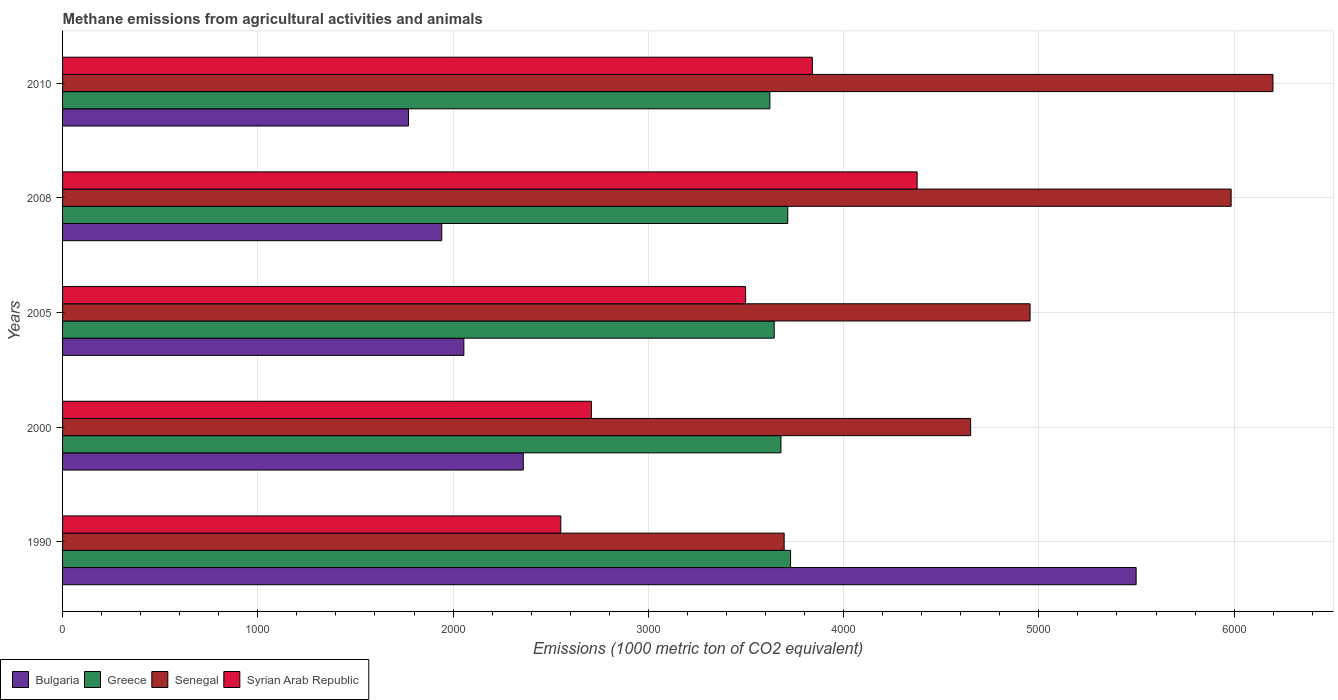How many different coloured bars are there?
Provide a succinct answer. 4. Are the number of bars on each tick of the Y-axis equal?
Your answer should be compact. Yes. How many bars are there on the 5th tick from the bottom?
Offer a very short reply. 4. In how many cases, is the number of bars for a given year not equal to the number of legend labels?
Your answer should be very brief. 0. What is the amount of methane emitted in Syrian Arab Republic in 2008?
Your response must be concise. 4376.8. Across all years, what is the maximum amount of methane emitted in Syrian Arab Republic?
Your answer should be very brief. 4376.8. Across all years, what is the minimum amount of methane emitted in Syrian Arab Republic?
Offer a very short reply. 2551.7. In which year was the amount of methane emitted in Bulgaria minimum?
Make the answer very short. 2010. What is the total amount of methane emitted in Syrian Arab Republic in the graph?
Make the answer very short. 1.70e+04. What is the difference between the amount of methane emitted in Greece in 2000 and that in 2005?
Ensure brevity in your answer.  34.7. What is the difference between the amount of methane emitted in Greece in 2010 and the amount of methane emitted in Bulgaria in 2005?
Offer a very short reply. 1567.2. What is the average amount of methane emitted in Greece per year?
Your answer should be compact. 3677.78. In the year 2000, what is the difference between the amount of methane emitted in Bulgaria and amount of methane emitted in Senegal?
Provide a short and direct response. -2291.2. What is the ratio of the amount of methane emitted in Senegal in 2000 to that in 2010?
Offer a terse response. 0.75. Is the difference between the amount of methane emitted in Bulgaria in 1990 and 2000 greater than the difference between the amount of methane emitted in Senegal in 1990 and 2000?
Make the answer very short. Yes. What is the difference between the highest and the second highest amount of methane emitted in Greece?
Your answer should be very brief. 14.4. What is the difference between the highest and the lowest amount of methane emitted in Senegal?
Keep it short and to the point. 2503.5. In how many years, is the amount of methane emitted in Greece greater than the average amount of methane emitted in Greece taken over all years?
Keep it short and to the point. 3. Is the sum of the amount of methane emitted in Senegal in 1990 and 2010 greater than the maximum amount of methane emitted in Greece across all years?
Ensure brevity in your answer.  Yes. Is it the case that in every year, the sum of the amount of methane emitted in Greece and amount of methane emitted in Syrian Arab Republic is greater than the sum of amount of methane emitted in Bulgaria and amount of methane emitted in Senegal?
Offer a terse response. No. What does the 3rd bar from the top in 2010 represents?
Your answer should be very brief. Greece. What does the 1st bar from the bottom in 2010 represents?
Your answer should be compact. Bulgaria. How many bars are there?
Keep it short and to the point. 20. Where does the legend appear in the graph?
Ensure brevity in your answer.  Bottom left. How many legend labels are there?
Your response must be concise. 4. How are the legend labels stacked?
Your response must be concise. Horizontal. What is the title of the graph?
Offer a terse response. Methane emissions from agricultural activities and animals. Does "Latvia" appear as one of the legend labels in the graph?
Provide a succinct answer. No. What is the label or title of the X-axis?
Your answer should be very brief. Emissions (1000 metric ton of CO2 equivalent). What is the label or title of the Y-axis?
Offer a terse response. Years. What is the Emissions (1000 metric ton of CO2 equivalent) of Bulgaria in 1990?
Give a very brief answer. 5498.3. What is the Emissions (1000 metric ton of CO2 equivalent) in Greece in 1990?
Your response must be concise. 3728.5. What is the Emissions (1000 metric ton of CO2 equivalent) of Senegal in 1990?
Your answer should be very brief. 3695.6. What is the Emissions (1000 metric ton of CO2 equivalent) of Syrian Arab Republic in 1990?
Your answer should be very brief. 2551.7. What is the Emissions (1000 metric ton of CO2 equivalent) in Bulgaria in 2000?
Keep it short and to the point. 2359.5. What is the Emissions (1000 metric ton of CO2 equivalent) of Greece in 2000?
Give a very brief answer. 3679.3. What is the Emissions (1000 metric ton of CO2 equivalent) in Senegal in 2000?
Offer a terse response. 4650.7. What is the Emissions (1000 metric ton of CO2 equivalent) in Syrian Arab Republic in 2000?
Ensure brevity in your answer.  2708.8. What is the Emissions (1000 metric ton of CO2 equivalent) in Bulgaria in 2005?
Provide a short and direct response. 2055.2. What is the Emissions (1000 metric ton of CO2 equivalent) of Greece in 2005?
Offer a terse response. 3644.6. What is the Emissions (1000 metric ton of CO2 equivalent) in Senegal in 2005?
Ensure brevity in your answer.  4955.1. What is the Emissions (1000 metric ton of CO2 equivalent) of Syrian Arab Republic in 2005?
Make the answer very short. 3498.3. What is the Emissions (1000 metric ton of CO2 equivalent) of Bulgaria in 2008?
Your response must be concise. 1942.2. What is the Emissions (1000 metric ton of CO2 equivalent) of Greece in 2008?
Keep it short and to the point. 3714.1. What is the Emissions (1000 metric ton of CO2 equivalent) of Senegal in 2008?
Provide a short and direct response. 5984.9. What is the Emissions (1000 metric ton of CO2 equivalent) of Syrian Arab Republic in 2008?
Your response must be concise. 4376.8. What is the Emissions (1000 metric ton of CO2 equivalent) in Bulgaria in 2010?
Ensure brevity in your answer.  1771.6. What is the Emissions (1000 metric ton of CO2 equivalent) in Greece in 2010?
Offer a very short reply. 3622.4. What is the Emissions (1000 metric ton of CO2 equivalent) in Senegal in 2010?
Ensure brevity in your answer.  6199.1. What is the Emissions (1000 metric ton of CO2 equivalent) of Syrian Arab Republic in 2010?
Provide a short and direct response. 3839.8. Across all years, what is the maximum Emissions (1000 metric ton of CO2 equivalent) of Bulgaria?
Your answer should be compact. 5498.3. Across all years, what is the maximum Emissions (1000 metric ton of CO2 equivalent) of Greece?
Ensure brevity in your answer.  3728.5. Across all years, what is the maximum Emissions (1000 metric ton of CO2 equivalent) of Senegal?
Your response must be concise. 6199.1. Across all years, what is the maximum Emissions (1000 metric ton of CO2 equivalent) of Syrian Arab Republic?
Your response must be concise. 4376.8. Across all years, what is the minimum Emissions (1000 metric ton of CO2 equivalent) of Bulgaria?
Provide a succinct answer. 1771.6. Across all years, what is the minimum Emissions (1000 metric ton of CO2 equivalent) in Greece?
Offer a terse response. 3622.4. Across all years, what is the minimum Emissions (1000 metric ton of CO2 equivalent) of Senegal?
Offer a very short reply. 3695.6. Across all years, what is the minimum Emissions (1000 metric ton of CO2 equivalent) of Syrian Arab Republic?
Your answer should be very brief. 2551.7. What is the total Emissions (1000 metric ton of CO2 equivalent) of Bulgaria in the graph?
Provide a succinct answer. 1.36e+04. What is the total Emissions (1000 metric ton of CO2 equivalent) in Greece in the graph?
Keep it short and to the point. 1.84e+04. What is the total Emissions (1000 metric ton of CO2 equivalent) in Senegal in the graph?
Keep it short and to the point. 2.55e+04. What is the total Emissions (1000 metric ton of CO2 equivalent) in Syrian Arab Republic in the graph?
Make the answer very short. 1.70e+04. What is the difference between the Emissions (1000 metric ton of CO2 equivalent) of Bulgaria in 1990 and that in 2000?
Keep it short and to the point. 3138.8. What is the difference between the Emissions (1000 metric ton of CO2 equivalent) in Greece in 1990 and that in 2000?
Make the answer very short. 49.2. What is the difference between the Emissions (1000 metric ton of CO2 equivalent) in Senegal in 1990 and that in 2000?
Make the answer very short. -955.1. What is the difference between the Emissions (1000 metric ton of CO2 equivalent) of Syrian Arab Republic in 1990 and that in 2000?
Offer a terse response. -157.1. What is the difference between the Emissions (1000 metric ton of CO2 equivalent) of Bulgaria in 1990 and that in 2005?
Your answer should be very brief. 3443.1. What is the difference between the Emissions (1000 metric ton of CO2 equivalent) of Greece in 1990 and that in 2005?
Provide a short and direct response. 83.9. What is the difference between the Emissions (1000 metric ton of CO2 equivalent) of Senegal in 1990 and that in 2005?
Keep it short and to the point. -1259.5. What is the difference between the Emissions (1000 metric ton of CO2 equivalent) in Syrian Arab Republic in 1990 and that in 2005?
Ensure brevity in your answer.  -946.6. What is the difference between the Emissions (1000 metric ton of CO2 equivalent) of Bulgaria in 1990 and that in 2008?
Give a very brief answer. 3556.1. What is the difference between the Emissions (1000 metric ton of CO2 equivalent) in Senegal in 1990 and that in 2008?
Ensure brevity in your answer.  -2289.3. What is the difference between the Emissions (1000 metric ton of CO2 equivalent) of Syrian Arab Republic in 1990 and that in 2008?
Provide a short and direct response. -1825.1. What is the difference between the Emissions (1000 metric ton of CO2 equivalent) in Bulgaria in 1990 and that in 2010?
Provide a succinct answer. 3726.7. What is the difference between the Emissions (1000 metric ton of CO2 equivalent) in Greece in 1990 and that in 2010?
Keep it short and to the point. 106.1. What is the difference between the Emissions (1000 metric ton of CO2 equivalent) in Senegal in 1990 and that in 2010?
Provide a short and direct response. -2503.5. What is the difference between the Emissions (1000 metric ton of CO2 equivalent) in Syrian Arab Republic in 1990 and that in 2010?
Your answer should be very brief. -1288.1. What is the difference between the Emissions (1000 metric ton of CO2 equivalent) in Bulgaria in 2000 and that in 2005?
Provide a succinct answer. 304.3. What is the difference between the Emissions (1000 metric ton of CO2 equivalent) of Greece in 2000 and that in 2005?
Keep it short and to the point. 34.7. What is the difference between the Emissions (1000 metric ton of CO2 equivalent) of Senegal in 2000 and that in 2005?
Your response must be concise. -304.4. What is the difference between the Emissions (1000 metric ton of CO2 equivalent) in Syrian Arab Republic in 2000 and that in 2005?
Provide a short and direct response. -789.5. What is the difference between the Emissions (1000 metric ton of CO2 equivalent) of Bulgaria in 2000 and that in 2008?
Keep it short and to the point. 417.3. What is the difference between the Emissions (1000 metric ton of CO2 equivalent) of Greece in 2000 and that in 2008?
Your response must be concise. -34.8. What is the difference between the Emissions (1000 metric ton of CO2 equivalent) of Senegal in 2000 and that in 2008?
Your answer should be very brief. -1334.2. What is the difference between the Emissions (1000 metric ton of CO2 equivalent) of Syrian Arab Republic in 2000 and that in 2008?
Your response must be concise. -1668. What is the difference between the Emissions (1000 metric ton of CO2 equivalent) of Bulgaria in 2000 and that in 2010?
Keep it short and to the point. 587.9. What is the difference between the Emissions (1000 metric ton of CO2 equivalent) in Greece in 2000 and that in 2010?
Provide a short and direct response. 56.9. What is the difference between the Emissions (1000 metric ton of CO2 equivalent) in Senegal in 2000 and that in 2010?
Keep it short and to the point. -1548.4. What is the difference between the Emissions (1000 metric ton of CO2 equivalent) in Syrian Arab Republic in 2000 and that in 2010?
Ensure brevity in your answer.  -1131. What is the difference between the Emissions (1000 metric ton of CO2 equivalent) of Bulgaria in 2005 and that in 2008?
Make the answer very short. 113. What is the difference between the Emissions (1000 metric ton of CO2 equivalent) of Greece in 2005 and that in 2008?
Offer a terse response. -69.5. What is the difference between the Emissions (1000 metric ton of CO2 equivalent) of Senegal in 2005 and that in 2008?
Provide a succinct answer. -1029.8. What is the difference between the Emissions (1000 metric ton of CO2 equivalent) of Syrian Arab Republic in 2005 and that in 2008?
Ensure brevity in your answer.  -878.5. What is the difference between the Emissions (1000 metric ton of CO2 equivalent) in Bulgaria in 2005 and that in 2010?
Offer a very short reply. 283.6. What is the difference between the Emissions (1000 metric ton of CO2 equivalent) in Greece in 2005 and that in 2010?
Your response must be concise. 22.2. What is the difference between the Emissions (1000 metric ton of CO2 equivalent) of Senegal in 2005 and that in 2010?
Give a very brief answer. -1244. What is the difference between the Emissions (1000 metric ton of CO2 equivalent) of Syrian Arab Republic in 2005 and that in 2010?
Ensure brevity in your answer.  -341.5. What is the difference between the Emissions (1000 metric ton of CO2 equivalent) of Bulgaria in 2008 and that in 2010?
Give a very brief answer. 170.6. What is the difference between the Emissions (1000 metric ton of CO2 equivalent) of Greece in 2008 and that in 2010?
Provide a succinct answer. 91.7. What is the difference between the Emissions (1000 metric ton of CO2 equivalent) of Senegal in 2008 and that in 2010?
Your answer should be very brief. -214.2. What is the difference between the Emissions (1000 metric ton of CO2 equivalent) in Syrian Arab Republic in 2008 and that in 2010?
Offer a very short reply. 537. What is the difference between the Emissions (1000 metric ton of CO2 equivalent) of Bulgaria in 1990 and the Emissions (1000 metric ton of CO2 equivalent) of Greece in 2000?
Keep it short and to the point. 1819. What is the difference between the Emissions (1000 metric ton of CO2 equivalent) of Bulgaria in 1990 and the Emissions (1000 metric ton of CO2 equivalent) of Senegal in 2000?
Provide a short and direct response. 847.6. What is the difference between the Emissions (1000 metric ton of CO2 equivalent) in Bulgaria in 1990 and the Emissions (1000 metric ton of CO2 equivalent) in Syrian Arab Republic in 2000?
Keep it short and to the point. 2789.5. What is the difference between the Emissions (1000 metric ton of CO2 equivalent) of Greece in 1990 and the Emissions (1000 metric ton of CO2 equivalent) of Senegal in 2000?
Provide a short and direct response. -922.2. What is the difference between the Emissions (1000 metric ton of CO2 equivalent) of Greece in 1990 and the Emissions (1000 metric ton of CO2 equivalent) of Syrian Arab Republic in 2000?
Make the answer very short. 1019.7. What is the difference between the Emissions (1000 metric ton of CO2 equivalent) of Senegal in 1990 and the Emissions (1000 metric ton of CO2 equivalent) of Syrian Arab Republic in 2000?
Keep it short and to the point. 986.8. What is the difference between the Emissions (1000 metric ton of CO2 equivalent) of Bulgaria in 1990 and the Emissions (1000 metric ton of CO2 equivalent) of Greece in 2005?
Offer a very short reply. 1853.7. What is the difference between the Emissions (1000 metric ton of CO2 equivalent) in Bulgaria in 1990 and the Emissions (1000 metric ton of CO2 equivalent) in Senegal in 2005?
Keep it short and to the point. 543.2. What is the difference between the Emissions (1000 metric ton of CO2 equivalent) of Bulgaria in 1990 and the Emissions (1000 metric ton of CO2 equivalent) of Syrian Arab Republic in 2005?
Provide a succinct answer. 2000. What is the difference between the Emissions (1000 metric ton of CO2 equivalent) of Greece in 1990 and the Emissions (1000 metric ton of CO2 equivalent) of Senegal in 2005?
Your response must be concise. -1226.6. What is the difference between the Emissions (1000 metric ton of CO2 equivalent) in Greece in 1990 and the Emissions (1000 metric ton of CO2 equivalent) in Syrian Arab Republic in 2005?
Give a very brief answer. 230.2. What is the difference between the Emissions (1000 metric ton of CO2 equivalent) of Senegal in 1990 and the Emissions (1000 metric ton of CO2 equivalent) of Syrian Arab Republic in 2005?
Ensure brevity in your answer.  197.3. What is the difference between the Emissions (1000 metric ton of CO2 equivalent) in Bulgaria in 1990 and the Emissions (1000 metric ton of CO2 equivalent) in Greece in 2008?
Make the answer very short. 1784.2. What is the difference between the Emissions (1000 metric ton of CO2 equivalent) in Bulgaria in 1990 and the Emissions (1000 metric ton of CO2 equivalent) in Senegal in 2008?
Keep it short and to the point. -486.6. What is the difference between the Emissions (1000 metric ton of CO2 equivalent) of Bulgaria in 1990 and the Emissions (1000 metric ton of CO2 equivalent) of Syrian Arab Republic in 2008?
Your answer should be very brief. 1121.5. What is the difference between the Emissions (1000 metric ton of CO2 equivalent) of Greece in 1990 and the Emissions (1000 metric ton of CO2 equivalent) of Senegal in 2008?
Offer a terse response. -2256.4. What is the difference between the Emissions (1000 metric ton of CO2 equivalent) in Greece in 1990 and the Emissions (1000 metric ton of CO2 equivalent) in Syrian Arab Republic in 2008?
Offer a terse response. -648.3. What is the difference between the Emissions (1000 metric ton of CO2 equivalent) in Senegal in 1990 and the Emissions (1000 metric ton of CO2 equivalent) in Syrian Arab Republic in 2008?
Make the answer very short. -681.2. What is the difference between the Emissions (1000 metric ton of CO2 equivalent) of Bulgaria in 1990 and the Emissions (1000 metric ton of CO2 equivalent) of Greece in 2010?
Your answer should be compact. 1875.9. What is the difference between the Emissions (1000 metric ton of CO2 equivalent) in Bulgaria in 1990 and the Emissions (1000 metric ton of CO2 equivalent) in Senegal in 2010?
Your response must be concise. -700.8. What is the difference between the Emissions (1000 metric ton of CO2 equivalent) in Bulgaria in 1990 and the Emissions (1000 metric ton of CO2 equivalent) in Syrian Arab Republic in 2010?
Make the answer very short. 1658.5. What is the difference between the Emissions (1000 metric ton of CO2 equivalent) of Greece in 1990 and the Emissions (1000 metric ton of CO2 equivalent) of Senegal in 2010?
Provide a short and direct response. -2470.6. What is the difference between the Emissions (1000 metric ton of CO2 equivalent) of Greece in 1990 and the Emissions (1000 metric ton of CO2 equivalent) of Syrian Arab Republic in 2010?
Your answer should be very brief. -111.3. What is the difference between the Emissions (1000 metric ton of CO2 equivalent) in Senegal in 1990 and the Emissions (1000 metric ton of CO2 equivalent) in Syrian Arab Republic in 2010?
Keep it short and to the point. -144.2. What is the difference between the Emissions (1000 metric ton of CO2 equivalent) in Bulgaria in 2000 and the Emissions (1000 metric ton of CO2 equivalent) in Greece in 2005?
Provide a short and direct response. -1285.1. What is the difference between the Emissions (1000 metric ton of CO2 equivalent) in Bulgaria in 2000 and the Emissions (1000 metric ton of CO2 equivalent) in Senegal in 2005?
Offer a very short reply. -2595.6. What is the difference between the Emissions (1000 metric ton of CO2 equivalent) in Bulgaria in 2000 and the Emissions (1000 metric ton of CO2 equivalent) in Syrian Arab Republic in 2005?
Offer a very short reply. -1138.8. What is the difference between the Emissions (1000 metric ton of CO2 equivalent) of Greece in 2000 and the Emissions (1000 metric ton of CO2 equivalent) of Senegal in 2005?
Provide a succinct answer. -1275.8. What is the difference between the Emissions (1000 metric ton of CO2 equivalent) in Greece in 2000 and the Emissions (1000 metric ton of CO2 equivalent) in Syrian Arab Republic in 2005?
Give a very brief answer. 181. What is the difference between the Emissions (1000 metric ton of CO2 equivalent) in Senegal in 2000 and the Emissions (1000 metric ton of CO2 equivalent) in Syrian Arab Republic in 2005?
Ensure brevity in your answer.  1152.4. What is the difference between the Emissions (1000 metric ton of CO2 equivalent) in Bulgaria in 2000 and the Emissions (1000 metric ton of CO2 equivalent) in Greece in 2008?
Make the answer very short. -1354.6. What is the difference between the Emissions (1000 metric ton of CO2 equivalent) of Bulgaria in 2000 and the Emissions (1000 metric ton of CO2 equivalent) of Senegal in 2008?
Offer a terse response. -3625.4. What is the difference between the Emissions (1000 metric ton of CO2 equivalent) in Bulgaria in 2000 and the Emissions (1000 metric ton of CO2 equivalent) in Syrian Arab Republic in 2008?
Offer a terse response. -2017.3. What is the difference between the Emissions (1000 metric ton of CO2 equivalent) of Greece in 2000 and the Emissions (1000 metric ton of CO2 equivalent) of Senegal in 2008?
Give a very brief answer. -2305.6. What is the difference between the Emissions (1000 metric ton of CO2 equivalent) of Greece in 2000 and the Emissions (1000 metric ton of CO2 equivalent) of Syrian Arab Republic in 2008?
Make the answer very short. -697.5. What is the difference between the Emissions (1000 metric ton of CO2 equivalent) of Senegal in 2000 and the Emissions (1000 metric ton of CO2 equivalent) of Syrian Arab Republic in 2008?
Your response must be concise. 273.9. What is the difference between the Emissions (1000 metric ton of CO2 equivalent) in Bulgaria in 2000 and the Emissions (1000 metric ton of CO2 equivalent) in Greece in 2010?
Offer a terse response. -1262.9. What is the difference between the Emissions (1000 metric ton of CO2 equivalent) in Bulgaria in 2000 and the Emissions (1000 metric ton of CO2 equivalent) in Senegal in 2010?
Offer a very short reply. -3839.6. What is the difference between the Emissions (1000 metric ton of CO2 equivalent) of Bulgaria in 2000 and the Emissions (1000 metric ton of CO2 equivalent) of Syrian Arab Republic in 2010?
Provide a short and direct response. -1480.3. What is the difference between the Emissions (1000 metric ton of CO2 equivalent) in Greece in 2000 and the Emissions (1000 metric ton of CO2 equivalent) in Senegal in 2010?
Offer a terse response. -2519.8. What is the difference between the Emissions (1000 metric ton of CO2 equivalent) of Greece in 2000 and the Emissions (1000 metric ton of CO2 equivalent) of Syrian Arab Republic in 2010?
Provide a short and direct response. -160.5. What is the difference between the Emissions (1000 metric ton of CO2 equivalent) in Senegal in 2000 and the Emissions (1000 metric ton of CO2 equivalent) in Syrian Arab Republic in 2010?
Offer a terse response. 810.9. What is the difference between the Emissions (1000 metric ton of CO2 equivalent) in Bulgaria in 2005 and the Emissions (1000 metric ton of CO2 equivalent) in Greece in 2008?
Ensure brevity in your answer.  -1658.9. What is the difference between the Emissions (1000 metric ton of CO2 equivalent) of Bulgaria in 2005 and the Emissions (1000 metric ton of CO2 equivalent) of Senegal in 2008?
Your answer should be very brief. -3929.7. What is the difference between the Emissions (1000 metric ton of CO2 equivalent) of Bulgaria in 2005 and the Emissions (1000 metric ton of CO2 equivalent) of Syrian Arab Republic in 2008?
Your answer should be compact. -2321.6. What is the difference between the Emissions (1000 metric ton of CO2 equivalent) of Greece in 2005 and the Emissions (1000 metric ton of CO2 equivalent) of Senegal in 2008?
Your response must be concise. -2340.3. What is the difference between the Emissions (1000 metric ton of CO2 equivalent) in Greece in 2005 and the Emissions (1000 metric ton of CO2 equivalent) in Syrian Arab Republic in 2008?
Keep it short and to the point. -732.2. What is the difference between the Emissions (1000 metric ton of CO2 equivalent) of Senegal in 2005 and the Emissions (1000 metric ton of CO2 equivalent) of Syrian Arab Republic in 2008?
Your answer should be compact. 578.3. What is the difference between the Emissions (1000 metric ton of CO2 equivalent) in Bulgaria in 2005 and the Emissions (1000 metric ton of CO2 equivalent) in Greece in 2010?
Provide a succinct answer. -1567.2. What is the difference between the Emissions (1000 metric ton of CO2 equivalent) in Bulgaria in 2005 and the Emissions (1000 metric ton of CO2 equivalent) in Senegal in 2010?
Offer a very short reply. -4143.9. What is the difference between the Emissions (1000 metric ton of CO2 equivalent) of Bulgaria in 2005 and the Emissions (1000 metric ton of CO2 equivalent) of Syrian Arab Republic in 2010?
Your response must be concise. -1784.6. What is the difference between the Emissions (1000 metric ton of CO2 equivalent) in Greece in 2005 and the Emissions (1000 metric ton of CO2 equivalent) in Senegal in 2010?
Offer a terse response. -2554.5. What is the difference between the Emissions (1000 metric ton of CO2 equivalent) of Greece in 2005 and the Emissions (1000 metric ton of CO2 equivalent) of Syrian Arab Republic in 2010?
Ensure brevity in your answer.  -195.2. What is the difference between the Emissions (1000 metric ton of CO2 equivalent) of Senegal in 2005 and the Emissions (1000 metric ton of CO2 equivalent) of Syrian Arab Republic in 2010?
Keep it short and to the point. 1115.3. What is the difference between the Emissions (1000 metric ton of CO2 equivalent) in Bulgaria in 2008 and the Emissions (1000 metric ton of CO2 equivalent) in Greece in 2010?
Your answer should be very brief. -1680.2. What is the difference between the Emissions (1000 metric ton of CO2 equivalent) in Bulgaria in 2008 and the Emissions (1000 metric ton of CO2 equivalent) in Senegal in 2010?
Keep it short and to the point. -4256.9. What is the difference between the Emissions (1000 metric ton of CO2 equivalent) in Bulgaria in 2008 and the Emissions (1000 metric ton of CO2 equivalent) in Syrian Arab Republic in 2010?
Offer a terse response. -1897.6. What is the difference between the Emissions (1000 metric ton of CO2 equivalent) in Greece in 2008 and the Emissions (1000 metric ton of CO2 equivalent) in Senegal in 2010?
Offer a very short reply. -2485. What is the difference between the Emissions (1000 metric ton of CO2 equivalent) in Greece in 2008 and the Emissions (1000 metric ton of CO2 equivalent) in Syrian Arab Republic in 2010?
Ensure brevity in your answer.  -125.7. What is the difference between the Emissions (1000 metric ton of CO2 equivalent) of Senegal in 2008 and the Emissions (1000 metric ton of CO2 equivalent) of Syrian Arab Republic in 2010?
Ensure brevity in your answer.  2145.1. What is the average Emissions (1000 metric ton of CO2 equivalent) in Bulgaria per year?
Ensure brevity in your answer.  2725.36. What is the average Emissions (1000 metric ton of CO2 equivalent) in Greece per year?
Your response must be concise. 3677.78. What is the average Emissions (1000 metric ton of CO2 equivalent) of Senegal per year?
Your response must be concise. 5097.08. What is the average Emissions (1000 metric ton of CO2 equivalent) in Syrian Arab Republic per year?
Ensure brevity in your answer.  3395.08. In the year 1990, what is the difference between the Emissions (1000 metric ton of CO2 equivalent) of Bulgaria and Emissions (1000 metric ton of CO2 equivalent) of Greece?
Offer a very short reply. 1769.8. In the year 1990, what is the difference between the Emissions (1000 metric ton of CO2 equivalent) of Bulgaria and Emissions (1000 metric ton of CO2 equivalent) of Senegal?
Offer a very short reply. 1802.7. In the year 1990, what is the difference between the Emissions (1000 metric ton of CO2 equivalent) of Bulgaria and Emissions (1000 metric ton of CO2 equivalent) of Syrian Arab Republic?
Your response must be concise. 2946.6. In the year 1990, what is the difference between the Emissions (1000 metric ton of CO2 equivalent) in Greece and Emissions (1000 metric ton of CO2 equivalent) in Senegal?
Offer a very short reply. 32.9. In the year 1990, what is the difference between the Emissions (1000 metric ton of CO2 equivalent) of Greece and Emissions (1000 metric ton of CO2 equivalent) of Syrian Arab Republic?
Give a very brief answer. 1176.8. In the year 1990, what is the difference between the Emissions (1000 metric ton of CO2 equivalent) of Senegal and Emissions (1000 metric ton of CO2 equivalent) of Syrian Arab Republic?
Provide a short and direct response. 1143.9. In the year 2000, what is the difference between the Emissions (1000 metric ton of CO2 equivalent) of Bulgaria and Emissions (1000 metric ton of CO2 equivalent) of Greece?
Offer a terse response. -1319.8. In the year 2000, what is the difference between the Emissions (1000 metric ton of CO2 equivalent) of Bulgaria and Emissions (1000 metric ton of CO2 equivalent) of Senegal?
Offer a terse response. -2291.2. In the year 2000, what is the difference between the Emissions (1000 metric ton of CO2 equivalent) of Bulgaria and Emissions (1000 metric ton of CO2 equivalent) of Syrian Arab Republic?
Your response must be concise. -349.3. In the year 2000, what is the difference between the Emissions (1000 metric ton of CO2 equivalent) of Greece and Emissions (1000 metric ton of CO2 equivalent) of Senegal?
Make the answer very short. -971.4. In the year 2000, what is the difference between the Emissions (1000 metric ton of CO2 equivalent) of Greece and Emissions (1000 metric ton of CO2 equivalent) of Syrian Arab Republic?
Your answer should be compact. 970.5. In the year 2000, what is the difference between the Emissions (1000 metric ton of CO2 equivalent) of Senegal and Emissions (1000 metric ton of CO2 equivalent) of Syrian Arab Republic?
Provide a short and direct response. 1941.9. In the year 2005, what is the difference between the Emissions (1000 metric ton of CO2 equivalent) in Bulgaria and Emissions (1000 metric ton of CO2 equivalent) in Greece?
Your answer should be very brief. -1589.4. In the year 2005, what is the difference between the Emissions (1000 metric ton of CO2 equivalent) in Bulgaria and Emissions (1000 metric ton of CO2 equivalent) in Senegal?
Your response must be concise. -2899.9. In the year 2005, what is the difference between the Emissions (1000 metric ton of CO2 equivalent) of Bulgaria and Emissions (1000 metric ton of CO2 equivalent) of Syrian Arab Republic?
Provide a short and direct response. -1443.1. In the year 2005, what is the difference between the Emissions (1000 metric ton of CO2 equivalent) in Greece and Emissions (1000 metric ton of CO2 equivalent) in Senegal?
Keep it short and to the point. -1310.5. In the year 2005, what is the difference between the Emissions (1000 metric ton of CO2 equivalent) in Greece and Emissions (1000 metric ton of CO2 equivalent) in Syrian Arab Republic?
Provide a short and direct response. 146.3. In the year 2005, what is the difference between the Emissions (1000 metric ton of CO2 equivalent) in Senegal and Emissions (1000 metric ton of CO2 equivalent) in Syrian Arab Republic?
Provide a short and direct response. 1456.8. In the year 2008, what is the difference between the Emissions (1000 metric ton of CO2 equivalent) of Bulgaria and Emissions (1000 metric ton of CO2 equivalent) of Greece?
Provide a short and direct response. -1771.9. In the year 2008, what is the difference between the Emissions (1000 metric ton of CO2 equivalent) in Bulgaria and Emissions (1000 metric ton of CO2 equivalent) in Senegal?
Make the answer very short. -4042.7. In the year 2008, what is the difference between the Emissions (1000 metric ton of CO2 equivalent) in Bulgaria and Emissions (1000 metric ton of CO2 equivalent) in Syrian Arab Republic?
Offer a very short reply. -2434.6. In the year 2008, what is the difference between the Emissions (1000 metric ton of CO2 equivalent) in Greece and Emissions (1000 metric ton of CO2 equivalent) in Senegal?
Offer a very short reply. -2270.8. In the year 2008, what is the difference between the Emissions (1000 metric ton of CO2 equivalent) in Greece and Emissions (1000 metric ton of CO2 equivalent) in Syrian Arab Republic?
Ensure brevity in your answer.  -662.7. In the year 2008, what is the difference between the Emissions (1000 metric ton of CO2 equivalent) of Senegal and Emissions (1000 metric ton of CO2 equivalent) of Syrian Arab Republic?
Provide a short and direct response. 1608.1. In the year 2010, what is the difference between the Emissions (1000 metric ton of CO2 equivalent) in Bulgaria and Emissions (1000 metric ton of CO2 equivalent) in Greece?
Your answer should be compact. -1850.8. In the year 2010, what is the difference between the Emissions (1000 metric ton of CO2 equivalent) in Bulgaria and Emissions (1000 metric ton of CO2 equivalent) in Senegal?
Keep it short and to the point. -4427.5. In the year 2010, what is the difference between the Emissions (1000 metric ton of CO2 equivalent) of Bulgaria and Emissions (1000 metric ton of CO2 equivalent) of Syrian Arab Republic?
Provide a succinct answer. -2068.2. In the year 2010, what is the difference between the Emissions (1000 metric ton of CO2 equivalent) in Greece and Emissions (1000 metric ton of CO2 equivalent) in Senegal?
Ensure brevity in your answer.  -2576.7. In the year 2010, what is the difference between the Emissions (1000 metric ton of CO2 equivalent) in Greece and Emissions (1000 metric ton of CO2 equivalent) in Syrian Arab Republic?
Offer a very short reply. -217.4. In the year 2010, what is the difference between the Emissions (1000 metric ton of CO2 equivalent) of Senegal and Emissions (1000 metric ton of CO2 equivalent) of Syrian Arab Republic?
Offer a terse response. 2359.3. What is the ratio of the Emissions (1000 metric ton of CO2 equivalent) in Bulgaria in 1990 to that in 2000?
Ensure brevity in your answer.  2.33. What is the ratio of the Emissions (1000 metric ton of CO2 equivalent) in Greece in 1990 to that in 2000?
Provide a succinct answer. 1.01. What is the ratio of the Emissions (1000 metric ton of CO2 equivalent) in Senegal in 1990 to that in 2000?
Provide a succinct answer. 0.79. What is the ratio of the Emissions (1000 metric ton of CO2 equivalent) in Syrian Arab Republic in 1990 to that in 2000?
Give a very brief answer. 0.94. What is the ratio of the Emissions (1000 metric ton of CO2 equivalent) of Bulgaria in 1990 to that in 2005?
Provide a short and direct response. 2.68. What is the ratio of the Emissions (1000 metric ton of CO2 equivalent) in Greece in 1990 to that in 2005?
Provide a succinct answer. 1.02. What is the ratio of the Emissions (1000 metric ton of CO2 equivalent) in Senegal in 1990 to that in 2005?
Your answer should be very brief. 0.75. What is the ratio of the Emissions (1000 metric ton of CO2 equivalent) of Syrian Arab Republic in 1990 to that in 2005?
Provide a succinct answer. 0.73. What is the ratio of the Emissions (1000 metric ton of CO2 equivalent) in Bulgaria in 1990 to that in 2008?
Provide a succinct answer. 2.83. What is the ratio of the Emissions (1000 metric ton of CO2 equivalent) of Greece in 1990 to that in 2008?
Provide a short and direct response. 1. What is the ratio of the Emissions (1000 metric ton of CO2 equivalent) in Senegal in 1990 to that in 2008?
Provide a short and direct response. 0.62. What is the ratio of the Emissions (1000 metric ton of CO2 equivalent) in Syrian Arab Republic in 1990 to that in 2008?
Your answer should be compact. 0.58. What is the ratio of the Emissions (1000 metric ton of CO2 equivalent) in Bulgaria in 1990 to that in 2010?
Your response must be concise. 3.1. What is the ratio of the Emissions (1000 metric ton of CO2 equivalent) of Greece in 1990 to that in 2010?
Your answer should be compact. 1.03. What is the ratio of the Emissions (1000 metric ton of CO2 equivalent) in Senegal in 1990 to that in 2010?
Offer a very short reply. 0.6. What is the ratio of the Emissions (1000 metric ton of CO2 equivalent) of Syrian Arab Republic in 1990 to that in 2010?
Provide a succinct answer. 0.66. What is the ratio of the Emissions (1000 metric ton of CO2 equivalent) in Bulgaria in 2000 to that in 2005?
Offer a very short reply. 1.15. What is the ratio of the Emissions (1000 metric ton of CO2 equivalent) of Greece in 2000 to that in 2005?
Keep it short and to the point. 1.01. What is the ratio of the Emissions (1000 metric ton of CO2 equivalent) of Senegal in 2000 to that in 2005?
Keep it short and to the point. 0.94. What is the ratio of the Emissions (1000 metric ton of CO2 equivalent) in Syrian Arab Republic in 2000 to that in 2005?
Ensure brevity in your answer.  0.77. What is the ratio of the Emissions (1000 metric ton of CO2 equivalent) in Bulgaria in 2000 to that in 2008?
Offer a terse response. 1.21. What is the ratio of the Emissions (1000 metric ton of CO2 equivalent) in Greece in 2000 to that in 2008?
Provide a short and direct response. 0.99. What is the ratio of the Emissions (1000 metric ton of CO2 equivalent) in Senegal in 2000 to that in 2008?
Offer a terse response. 0.78. What is the ratio of the Emissions (1000 metric ton of CO2 equivalent) of Syrian Arab Republic in 2000 to that in 2008?
Make the answer very short. 0.62. What is the ratio of the Emissions (1000 metric ton of CO2 equivalent) in Bulgaria in 2000 to that in 2010?
Your answer should be very brief. 1.33. What is the ratio of the Emissions (1000 metric ton of CO2 equivalent) of Greece in 2000 to that in 2010?
Provide a succinct answer. 1.02. What is the ratio of the Emissions (1000 metric ton of CO2 equivalent) of Senegal in 2000 to that in 2010?
Provide a succinct answer. 0.75. What is the ratio of the Emissions (1000 metric ton of CO2 equivalent) of Syrian Arab Republic in 2000 to that in 2010?
Provide a succinct answer. 0.71. What is the ratio of the Emissions (1000 metric ton of CO2 equivalent) in Bulgaria in 2005 to that in 2008?
Your answer should be very brief. 1.06. What is the ratio of the Emissions (1000 metric ton of CO2 equivalent) in Greece in 2005 to that in 2008?
Offer a very short reply. 0.98. What is the ratio of the Emissions (1000 metric ton of CO2 equivalent) of Senegal in 2005 to that in 2008?
Provide a succinct answer. 0.83. What is the ratio of the Emissions (1000 metric ton of CO2 equivalent) in Syrian Arab Republic in 2005 to that in 2008?
Keep it short and to the point. 0.8. What is the ratio of the Emissions (1000 metric ton of CO2 equivalent) in Bulgaria in 2005 to that in 2010?
Keep it short and to the point. 1.16. What is the ratio of the Emissions (1000 metric ton of CO2 equivalent) in Senegal in 2005 to that in 2010?
Give a very brief answer. 0.8. What is the ratio of the Emissions (1000 metric ton of CO2 equivalent) in Syrian Arab Republic in 2005 to that in 2010?
Your response must be concise. 0.91. What is the ratio of the Emissions (1000 metric ton of CO2 equivalent) of Bulgaria in 2008 to that in 2010?
Your answer should be compact. 1.1. What is the ratio of the Emissions (1000 metric ton of CO2 equivalent) in Greece in 2008 to that in 2010?
Provide a short and direct response. 1.03. What is the ratio of the Emissions (1000 metric ton of CO2 equivalent) in Senegal in 2008 to that in 2010?
Your answer should be very brief. 0.97. What is the ratio of the Emissions (1000 metric ton of CO2 equivalent) of Syrian Arab Republic in 2008 to that in 2010?
Make the answer very short. 1.14. What is the difference between the highest and the second highest Emissions (1000 metric ton of CO2 equivalent) of Bulgaria?
Provide a short and direct response. 3138.8. What is the difference between the highest and the second highest Emissions (1000 metric ton of CO2 equivalent) of Senegal?
Offer a terse response. 214.2. What is the difference between the highest and the second highest Emissions (1000 metric ton of CO2 equivalent) of Syrian Arab Republic?
Provide a short and direct response. 537. What is the difference between the highest and the lowest Emissions (1000 metric ton of CO2 equivalent) in Bulgaria?
Your answer should be compact. 3726.7. What is the difference between the highest and the lowest Emissions (1000 metric ton of CO2 equivalent) in Greece?
Keep it short and to the point. 106.1. What is the difference between the highest and the lowest Emissions (1000 metric ton of CO2 equivalent) in Senegal?
Ensure brevity in your answer.  2503.5. What is the difference between the highest and the lowest Emissions (1000 metric ton of CO2 equivalent) in Syrian Arab Republic?
Ensure brevity in your answer.  1825.1. 